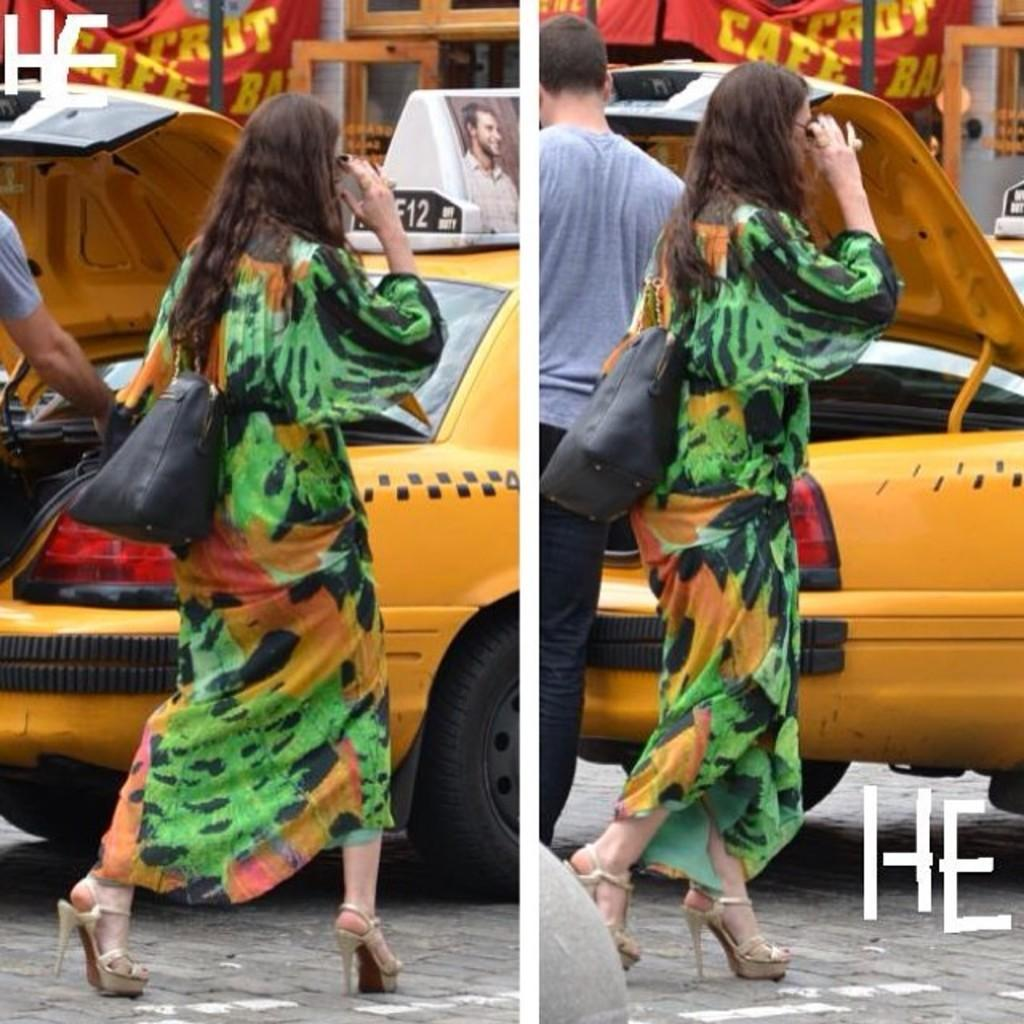<image>
Summarize the visual content of the image. A lady wearing a green dress walking  by a yellow taxi that says F12 on top. 